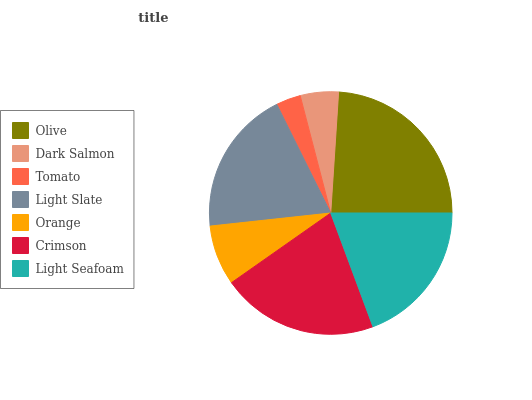Is Tomato the minimum?
Answer yes or no. Yes. Is Olive the maximum?
Answer yes or no. Yes. Is Dark Salmon the minimum?
Answer yes or no. No. Is Dark Salmon the maximum?
Answer yes or no. No. Is Olive greater than Dark Salmon?
Answer yes or no. Yes. Is Dark Salmon less than Olive?
Answer yes or no. Yes. Is Dark Salmon greater than Olive?
Answer yes or no. No. Is Olive less than Dark Salmon?
Answer yes or no. No. Is Light Seafoam the high median?
Answer yes or no. Yes. Is Light Seafoam the low median?
Answer yes or no. Yes. Is Crimson the high median?
Answer yes or no. No. Is Olive the low median?
Answer yes or no. No. 